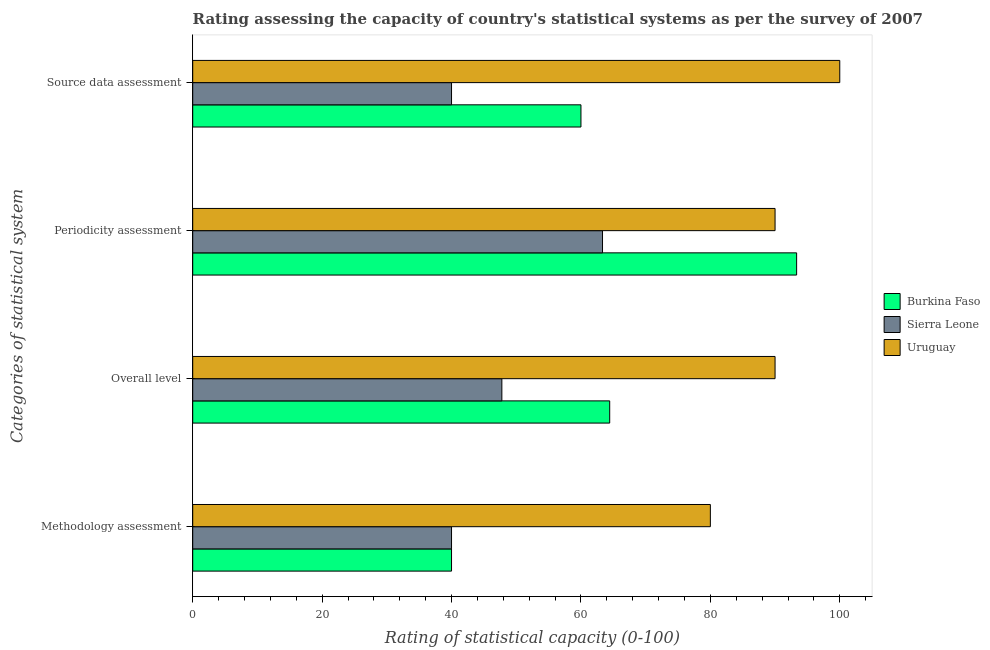How many different coloured bars are there?
Your response must be concise. 3. Are the number of bars on each tick of the Y-axis equal?
Your answer should be very brief. Yes. How many bars are there on the 4th tick from the bottom?
Offer a terse response. 3. What is the label of the 4th group of bars from the top?
Your answer should be very brief. Methodology assessment. What is the overall level rating in Uruguay?
Make the answer very short. 90. Across all countries, what is the minimum source data assessment rating?
Keep it short and to the point. 40. In which country was the overall level rating maximum?
Your response must be concise. Uruguay. In which country was the methodology assessment rating minimum?
Keep it short and to the point. Burkina Faso. What is the total periodicity assessment rating in the graph?
Make the answer very short. 246.67. What is the difference between the overall level rating in Burkina Faso and the methodology assessment rating in Sierra Leone?
Give a very brief answer. 24.44. What is the average overall level rating per country?
Offer a very short reply. 67.41. What is the difference between the periodicity assessment rating and source data assessment rating in Burkina Faso?
Ensure brevity in your answer.  33.33. In how many countries, is the periodicity assessment rating greater than 92 ?
Your answer should be compact. 1. Is the difference between the methodology assessment rating in Uruguay and Burkina Faso greater than the difference between the source data assessment rating in Uruguay and Burkina Faso?
Ensure brevity in your answer.  No. What is the difference between the highest and the second highest source data assessment rating?
Keep it short and to the point. 40. What is the difference between the highest and the lowest overall level rating?
Your answer should be compact. 42.22. In how many countries, is the overall level rating greater than the average overall level rating taken over all countries?
Offer a very short reply. 1. Is the sum of the source data assessment rating in Burkina Faso and Uruguay greater than the maximum methodology assessment rating across all countries?
Give a very brief answer. Yes. What does the 2nd bar from the top in Methodology assessment represents?
Offer a very short reply. Sierra Leone. What does the 1st bar from the bottom in Periodicity assessment represents?
Provide a succinct answer. Burkina Faso. Are all the bars in the graph horizontal?
Keep it short and to the point. Yes. How many countries are there in the graph?
Make the answer very short. 3. What is the difference between two consecutive major ticks on the X-axis?
Make the answer very short. 20. How many legend labels are there?
Offer a very short reply. 3. What is the title of the graph?
Make the answer very short. Rating assessing the capacity of country's statistical systems as per the survey of 2007 . What is the label or title of the X-axis?
Offer a very short reply. Rating of statistical capacity (0-100). What is the label or title of the Y-axis?
Offer a very short reply. Categories of statistical system. What is the Rating of statistical capacity (0-100) in Burkina Faso in Methodology assessment?
Your answer should be compact. 40. What is the Rating of statistical capacity (0-100) in Burkina Faso in Overall level?
Your response must be concise. 64.44. What is the Rating of statistical capacity (0-100) in Sierra Leone in Overall level?
Your answer should be compact. 47.78. What is the Rating of statistical capacity (0-100) of Burkina Faso in Periodicity assessment?
Give a very brief answer. 93.33. What is the Rating of statistical capacity (0-100) of Sierra Leone in Periodicity assessment?
Provide a short and direct response. 63.33. What is the Rating of statistical capacity (0-100) in Uruguay in Periodicity assessment?
Provide a succinct answer. 90. What is the Rating of statistical capacity (0-100) of Burkina Faso in Source data assessment?
Make the answer very short. 60. Across all Categories of statistical system, what is the maximum Rating of statistical capacity (0-100) of Burkina Faso?
Your response must be concise. 93.33. Across all Categories of statistical system, what is the maximum Rating of statistical capacity (0-100) in Sierra Leone?
Your answer should be compact. 63.33. Across all Categories of statistical system, what is the minimum Rating of statistical capacity (0-100) in Sierra Leone?
Your answer should be very brief. 40. Across all Categories of statistical system, what is the minimum Rating of statistical capacity (0-100) in Uruguay?
Offer a very short reply. 80. What is the total Rating of statistical capacity (0-100) in Burkina Faso in the graph?
Make the answer very short. 257.78. What is the total Rating of statistical capacity (0-100) in Sierra Leone in the graph?
Give a very brief answer. 191.11. What is the total Rating of statistical capacity (0-100) in Uruguay in the graph?
Keep it short and to the point. 360. What is the difference between the Rating of statistical capacity (0-100) in Burkina Faso in Methodology assessment and that in Overall level?
Provide a short and direct response. -24.44. What is the difference between the Rating of statistical capacity (0-100) of Sierra Leone in Methodology assessment and that in Overall level?
Offer a terse response. -7.78. What is the difference between the Rating of statistical capacity (0-100) of Uruguay in Methodology assessment and that in Overall level?
Provide a succinct answer. -10. What is the difference between the Rating of statistical capacity (0-100) in Burkina Faso in Methodology assessment and that in Periodicity assessment?
Your response must be concise. -53.33. What is the difference between the Rating of statistical capacity (0-100) in Sierra Leone in Methodology assessment and that in Periodicity assessment?
Make the answer very short. -23.33. What is the difference between the Rating of statistical capacity (0-100) in Uruguay in Methodology assessment and that in Periodicity assessment?
Keep it short and to the point. -10. What is the difference between the Rating of statistical capacity (0-100) in Burkina Faso in Methodology assessment and that in Source data assessment?
Provide a short and direct response. -20. What is the difference between the Rating of statistical capacity (0-100) of Uruguay in Methodology assessment and that in Source data assessment?
Your answer should be very brief. -20. What is the difference between the Rating of statistical capacity (0-100) of Burkina Faso in Overall level and that in Periodicity assessment?
Provide a short and direct response. -28.89. What is the difference between the Rating of statistical capacity (0-100) in Sierra Leone in Overall level and that in Periodicity assessment?
Keep it short and to the point. -15.56. What is the difference between the Rating of statistical capacity (0-100) in Burkina Faso in Overall level and that in Source data assessment?
Keep it short and to the point. 4.44. What is the difference between the Rating of statistical capacity (0-100) in Sierra Leone in Overall level and that in Source data assessment?
Provide a succinct answer. 7.78. What is the difference between the Rating of statistical capacity (0-100) in Burkina Faso in Periodicity assessment and that in Source data assessment?
Your response must be concise. 33.33. What is the difference between the Rating of statistical capacity (0-100) of Sierra Leone in Periodicity assessment and that in Source data assessment?
Give a very brief answer. 23.33. What is the difference between the Rating of statistical capacity (0-100) of Burkina Faso in Methodology assessment and the Rating of statistical capacity (0-100) of Sierra Leone in Overall level?
Your answer should be compact. -7.78. What is the difference between the Rating of statistical capacity (0-100) of Burkina Faso in Methodology assessment and the Rating of statistical capacity (0-100) of Uruguay in Overall level?
Provide a succinct answer. -50. What is the difference between the Rating of statistical capacity (0-100) in Burkina Faso in Methodology assessment and the Rating of statistical capacity (0-100) in Sierra Leone in Periodicity assessment?
Your response must be concise. -23.33. What is the difference between the Rating of statistical capacity (0-100) of Burkina Faso in Methodology assessment and the Rating of statistical capacity (0-100) of Uruguay in Periodicity assessment?
Your answer should be very brief. -50. What is the difference between the Rating of statistical capacity (0-100) in Burkina Faso in Methodology assessment and the Rating of statistical capacity (0-100) in Uruguay in Source data assessment?
Your answer should be compact. -60. What is the difference between the Rating of statistical capacity (0-100) of Sierra Leone in Methodology assessment and the Rating of statistical capacity (0-100) of Uruguay in Source data assessment?
Ensure brevity in your answer.  -60. What is the difference between the Rating of statistical capacity (0-100) in Burkina Faso in Overall level and the Rating of statistical capacity (0-100) in Uruguay in Periodicity assessment?
Offer a very short reply. -25.56. What is the difference between the Rating of statistical capacity (0-100) in Sierra Leone in Overall level and the Rating of statistical capacity (0-100) in Uruguay in Periodicity assessment?
Provide a succinct answer. -42.22. What is the difference between the Rating of statistical capacity (0-100) in Burkina Faso in Overall level and the Rating of statistical capacity (0-100) in Sierra Leone in Source data assessment?
Ensure brevity in your answer.  24.44. What is the difference between the Rating of statistical capacity (0-100) in Burkina Faso in Overall level and the Rating of statistical capacity (0-100) in Uruguay in Source data assessment?
Provide a succinct answer. -35.56. What is the difference between the Rating of statistical capacity (0-100) of Sierra Leone in Overall level and the Rating of statistical capacity (0-100) of Uruguay in Source data assessment?
Offer a very short reply. -52.22. What is the difference between the Rating of statistical capacity (0-100) of Burkina Faso in Periodicity assessment and the Rating of statistical capacity (0-100) of Sierra Leone in Source data assessment?
Provide a succinct answer. 53.33. What is the difference between the Rating of statistical capacity (0-100) in Burkina Faso in Periodicity assessment and the Rating of statistical capacity (0-100) in Uruguay in Source data assessment?
Keep it short and to the point. -6.67. What is the difference between the Rating of statistical capacity (0-100) of Sierra Leone in Periodicity assessment and the Rating of statistical capacity (0-100) of Uruguay in Source data assessment?
Your answer should be compact. -36.67. What is the average Rating of statistical capacity (0-100) in Burkina Faso per Categories of statistical system?
Your answer should be very brief. 64.44. What is the average Rating of statistical capacity (0-100) in Sierra Leone per Categories of statistical system?
Your answer should be very brief. 47.78. What is the average Rating of statistical capacity (0-100) in Uruguay per Categories of statistical system?
Keep it short and to the point. 90. What is the difference between the Rating of statistical capacity (0-100) of Burkina Faso and Rating of statistical capacity (0-100) of Uruguay in Methodology assessment?
Your answer should be compact. -40. What is the difference between the Rating of statistical capacity (0-100) in Burkina Faso and Rating of statistical capacity (0-100) in Sierra Leone in Overall level?
Give a very brief answer. 16.67. What is the difference between the Rating of statistical capacity (0-100) in Burkina Faso and Rating of statistical capacity (0-100) in Uruguay in Overall level?
Ensure brevity in your answer.  -25.56. What is the difference between the Rating of statistical capacity (0-100) in Sierra Leone and Rating of statistical capacity (0-100) in Uruguay in Overall level?
Provide a succinct answer. -42.22. What is the difference between the Rating of statistical capacity (0-100) in Burkina Faso and Rating of statistical capacity (0-100) in Uruguay in Periodicity assessment?
Offer a very short reply. 3.33. What is the difference between the Rating of statistical capacity (0-100) in Sierra Leone and Rating of statistical capacity (0-100) in Uruguay in Periodicity assessment?
Provide a short and direct response. -26.67. What is the difference between the Rating of statistical capacity (0-100) in Burkina Faso and Rating of statistical capacity (0-100) in Sierra Leone in Source data assessment?
Ensure brevity in your answer.  20. What is the difference between the Rating of statistical capacity (0-100) of Burkina Faso and Rating of statistical capacity (0-100) of Uruguay in Source data assessment?
Your answer should be very brief. -40. What is the difference between the Rating of statistical capacity (0-100) of Sierra Leone and Rating of statistical capacity (0-100) of Uruguay in Source data assessment?
Ensure brevity in your answer.  -60. What is the ratio of the Rating of statistical capacity (0-100) in Burkina Faso in Methodology assessment to that in Overall level?
Provide a short and direct response. 0.62. What is the ratio of the Rating of statistical capacity (0-100) in Sierra Leone in Methodology assessment to that in Overall level?
Your response must be concise. 0.84. What is the ratio of the Rating of statistical capacity (0-100) of Burkina Faso in Methodology assessment to that in Periodicity assessment?
Give a very brief answer. 0.43. What is the ratio of the Rating of statistical capacity (0-100) of Sierra Leone in Methodology assessment to that in Periodicity assessment?
Ensure brevity in your answer.  0.63. What is the ratio of the Rating of statistical capacity (0-100) in Uruguay in Methodology assessment to that in Periodicity assessment?
Make the answer very short. 0.89. What is the ratio of the Rating of statistical capacity (0-100) of Uruguay in Methodology assessment to that in Source data assessment?
Your answer should be compact. 0.8. What is the ratio of the Rating of statistical capacity (0-100) in Burkina Faso in Overall level to that in Periodicity assessment?
Make the answer very short. 0.69. What is the ratio of the Rating of statistical capacity (0-100) in Sierra Leone in Overall level to that in Periodicity assessment?
Offer a very short reply. 0.75. What is the ratio of the Rating of statistical capacity (0-100) of Uruguay in Overall level to that in Periodicity assessment?
Provide a succinct answer. 1. What is the ratio of the Rating of statistical capacity (0-100) of Burkina Faso in Overall level to that in Source data assessment?
Ensure brevity in your answer.  1.07. What is the ratio of the Rating of statistical capacity (0-100) of Sierra Leone in Overall level to that in Source data assessment?
Keep it short and to the point. 1.19. What is the ratio of the Rating of statistical capacity (0-100) of Burkina Faso in Periodicity assessment to that in Source data assessment?
Your response must be concise. 1.56. What is the ratio of the Rating of statistical capacity (0-100) in Sierra Leone in Periodicity assessment to that in Source data assessment?
Offer a very short reply. 1.58. What is the difference between the highest and the second highest Rating of statistical capacity (0-100) in Burkina Faso?
Provide a short and direct response. 28.89. What is the difference between the highest and the second highest Rating of statistical capacity (0-100) of Sierra Leone?
Your answer should be very brief. 15.56. What is the difference between the highest and the second highest Rating of statistical capacity (0-100) in Uruguay?
Offer a terse response. 10. What is the difference between the highest and the lowest Rating of statistical capacity (0-100) in Burkina Faso?
Provide a short and direct response. 53.33. What is the difference between the highest and the lowest Rating of statistical capacity (0-100) in Sierra Leone?
Ensure brevity in your answer.  23.33. 